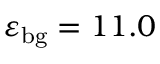Convert formula to latex. <formula><loc_0><loc_0><loc_500><loc_500>\varepsilon _ { b g } = 1 1 . 0</formula> 